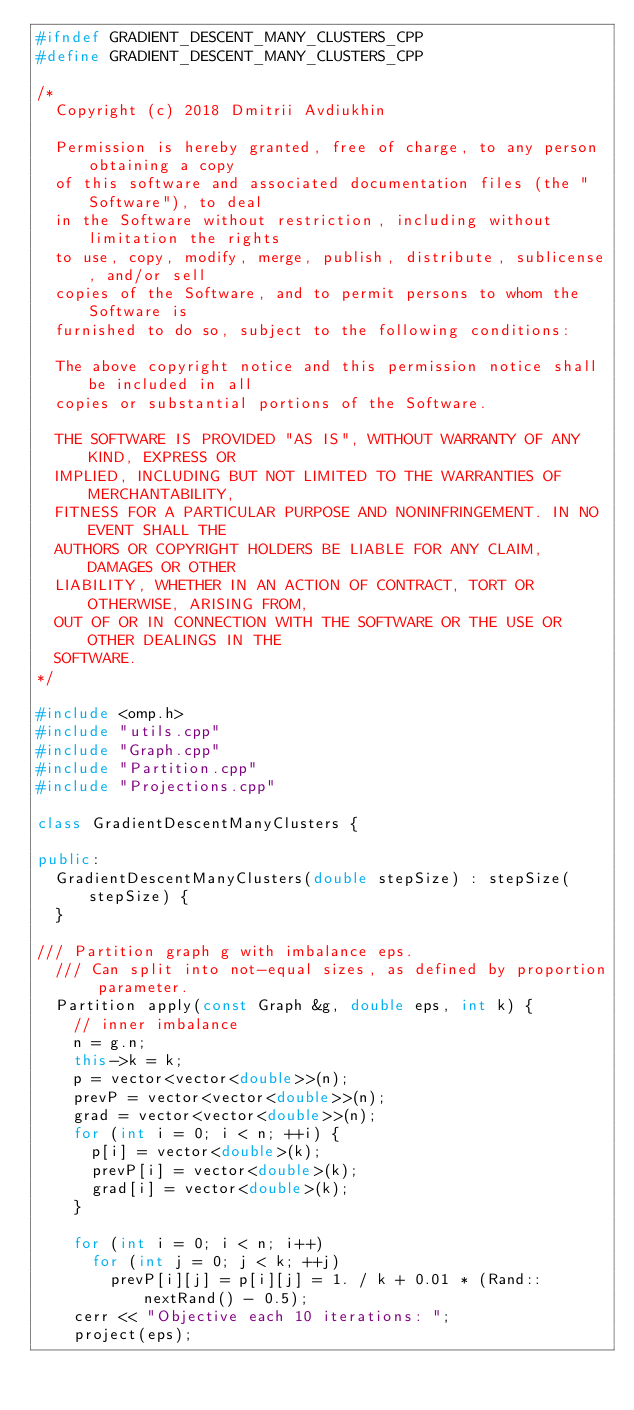<code> <loc_0><loc_0><loc_500><loc_500><_C++_>#ifndef GRADIENT_DESCENT_MANY_CLUSTERS_CPP
#define GRADIENT_DESCENT_MANY_CLUSTERS_CPP

/*
  Copyright (c) 2018 Dmitrii Avdiukhin

  Permission is hereby granted, free of charge, to any person obtaining a copy
  of this software and associated documentation files (the "Software"), to deal
  in the Software without restriction, including without limitation the rights
  to use, copy, modify, merge, publish, distribute, sublicense, and/or sell
  copies of the Software, and to permit persons to whom the Software is
  furnished to do so, subject to the following conditions:

  The above copyright notice and this permission notice shall be included in all
  copies or substantial portions of the Software.

  THE SOFTWARE IS PROVIDED "AS IS", WITHOUT WARRANTY OF ANY KIND, EXPRESS OR
  IMPLIED, INCLUDING BUT NOT LIMITED TO THE WARRANTIES OF MERCHANTABILITY,
  FITNESS FOR A PARTICULAR PURPOSE AND NONINFRINGEMENT. IN NO EVENT SHALL THE
  AUTHORS OR COPYRIGHT HOLDERS BE LIABLE FOR ANY CLAIM, DAMAGES OR OTHER
  LIABILITY, WHETHER IN AN ACTION OF CONTRACT, TORT OR OTHERWISE, ARISING FROM,
  OUT OF OR IN CONNECTION WITH THE SOFTWARE OR THE USE OR OTHER DEALINGS IN THE
  SOFTWARE.
*/

#include <omp.h>
#include "utils.cpp"
#include "Graph.cpp"
#include "Partition.cpp"
#include "Projections.cpp"

class GradientDescentManyClusters {

public:
  GradientDescentManyClusters(double stepSize) : stepSize(stepSize) {
  }

/// Partition graph g with imbalance eps.
  /// Can split into not-equal sizes, as defined by proportion parameter.
  Partition apply(const Graph &g, double eps, int k) {
    // inner imbalance
    n = g.n;
    this->k = k;
    p = vector<vector<double>>(n);
    prevP = vector<vector<double>>(n);
    grad = vector<vector<double>>(n);
    for (int i = 0; i < n; ++i) {
      p[i] = vector<double>(k);
      prevP[i] = vector<double>(k);
      grad[i] = vector<double>(k);
    }

    for (int i = 0; i < n; i++)
      for (int j = 0; j < k; ++j)
        prevP[i][j] = p[i][j] = 1. / k + 0.01 * (Rand::nextRand() - 0.5);
    cerr << "Objective each 10 iterations: ";
    project(eps);
</code> 